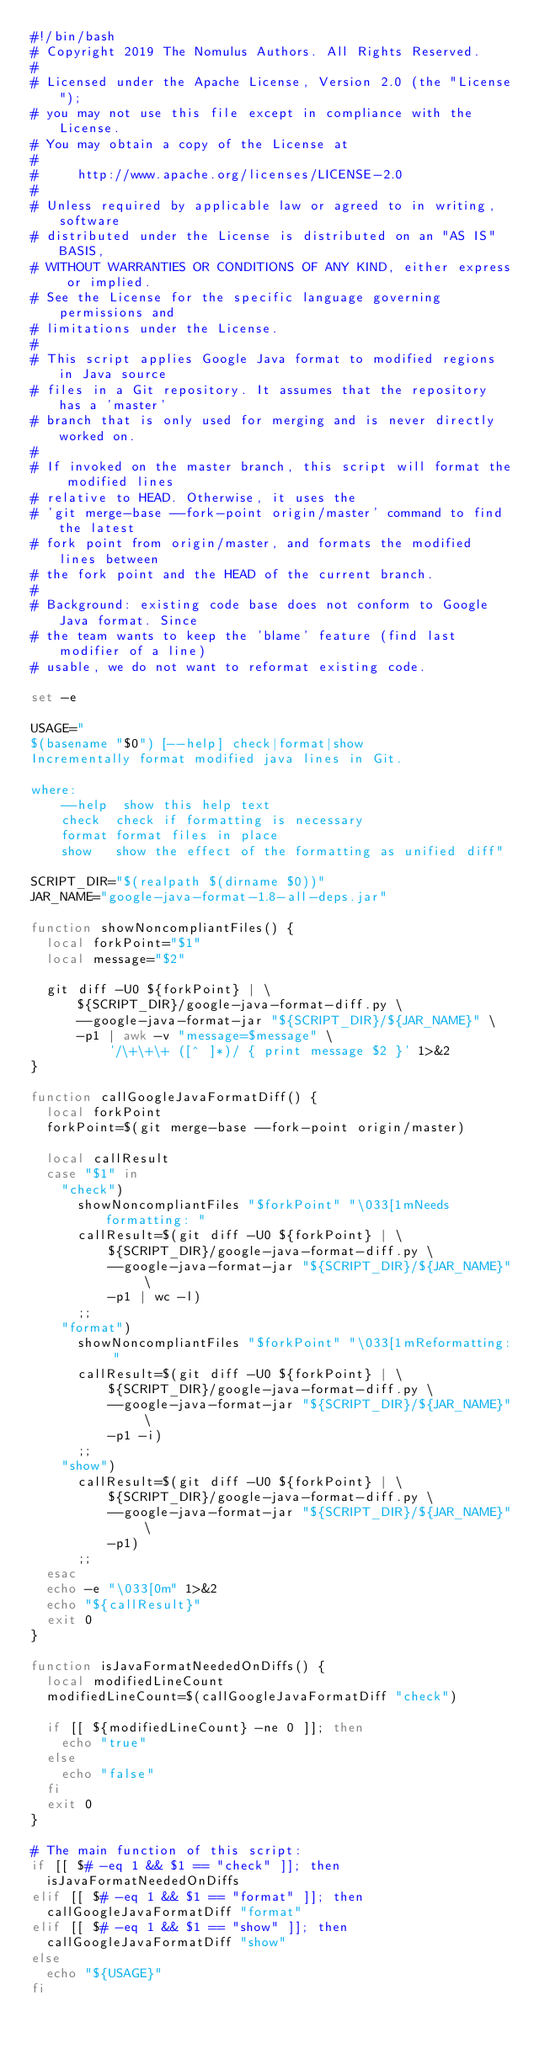Convert code to text. <code><loc_0><loc_0><loc_500><loc_500><_Bash_>#!/bin/bash
# Copyright 2019 The Nomulus Authors. All Rights Reserved.
#
# Licensed under the Apache License, Version 2.0 (the "License");
# you may not use this file except in compliance with the License.
# You may obtain a copy of the License at
#
#     http://www.apache.org/licenses/LICENSE-2.0
#
# Unless required by applicable law or agreed to in writing, software
# distributed under the License is distributed on an "AS IS" BASIS,
# WITHOUT WARRANTIES OR CONDITIONS OF ANY KIND, either express or implied.
# See the License for the specific language governing permissions and
# limitations under the License.
#
# This script applies Google Java format to modified regions in Java source
# files in a Git repository. It assumes that the repository has a 'master'
# branch that is only used for merging and is never directly worked on.
#
# If invoked on the master branch, this script will format the modified lines
# relative to HEAD. Otherwise, it uses the
# 'git merge-base --fork-point origin/master' command to find the latest
# fork point from origin/master, and formats the modified lines between
# the fork point and the HEAD of the current branch.
#
# Background: existing code base does not conform to Google Java format. Since
# the team wants to keep the 'blame' feature (find last modifier of a line)
# usable, we do not want to reformat existing code.

set -e

USAGE="
$(basename "$0") [--help] check|format|show
Incrementally format modified java lines in Git.

where:
    --help  show this help text
    check  check if formatting is necessary
    format format files in place
    show   show the effect of the formatting as unified diff"

SCRIPT_DIR="$(realpath $(dirname $0))"
JAR_NAME="google-java-format-1.8-all-deps.jar"

function showNoncompliantFiles() {
  local forkPoint="$1"
  local message="$2"

  git diff -U0 ${forkPoint} | \
      ${SCRIPT_DIR}/google-java-format-diff.py \
      --google-java-format-jar "${SCRIPT_DIR}/${JAR_NAME}" \
      -p1 | awk -v "message=$message" \
          '/\+\+\+ ([^ ]*)/ { print message $2 }' 1>&2
}

function callGoogleJavaFormatDiff() {
  local forkPoint
  forkPoint=$(git merge-base --fork-point origin/master)

  local callResult
  case "$1" in
    "check")
      showNoncompliantFiles "$forkPoint" "\033[1mNeeds formatting: "
      callResult=$(git diff -U0 ${forkPoint} | \
          ${SCRIPT_DIR}/google-java-format-diff.py \
          --google-java-format-jar "${SCRIPT_DIR}/${JAR_NAME}" \
          -p1 | wc -l)
      ;;
    "format")
      showNoncompliantFiles "$forkPoint" "\033[1mReformatting: "
      callResult=$(git diff -U0 ${forkPoint} | \
          ${SCRIPT_DIR}/google-java-format-diff.py \
          --google-java-format-jar "${SCRIPT_DIR}/${JAR_NAME}" \
          -p1 -i)
      ;;
    "show")
      callResult=$(git diff -U0 ${forkPoint} | \
          ${SCRIPT_DIR}/google-java-format-diff.py \
          --google-java-format-jar "${SCRIPT_DIR}/${JAR_NAME}" \
          -p1)
      ;;
  esac
  echo -e "\033[0m" 1>&2
  echo "${callResult}"
  exit 0
}

function isJavaFormatNeededOnDiffs() {
  local modifiedLineCount
  modifiedLineCount=$(callGoogleJavaFormatDiff "check")

  if [[ ${modifiedLineCount} -ne 0 ]]; then
    echo "true"
  else
    echo "false"
  fi
  exit 0
}

# The main function of this script:
if [[ $# -eq 1 && $1 == "check" ]]; then
  isJavaFormatNeededOnDiffs
elif [[ $# -eq 1 && $1 == "format" ]]; then
  callGoogleJavaFormatDiff "format"
elif [[ $# -eq 1 && $1 == "show" ]]; then
  callGoogleJavaFormatDiff "show"
else
  echo "${USAGE}"
fi
</code> 